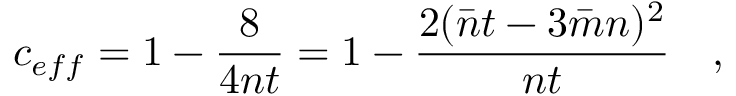Convert formula to latex. <formula><loc_0><loc_0><loc_500><loc_500>c _ { e f f } = 1 - \frac { 8 } { 4 n t } = 1 - \frac { 2 ( \bar { n } t - 3 \bar { m } n ) ^ { 2 } } { n t } \quad ,</formula> 